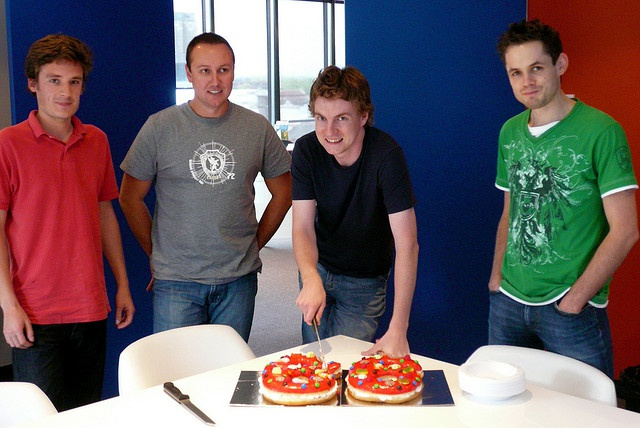Describe the objects in this image and their specific colors. I can see people in gray, darkgreen, black, green, and brown tones, people in gray, brown, black, and maroon tones, people in gray, maroon, black, and brown tones, dining table in gray, white, red, and tan tones, and people in gray, black, salmon, brown, and navy tones in this image. 